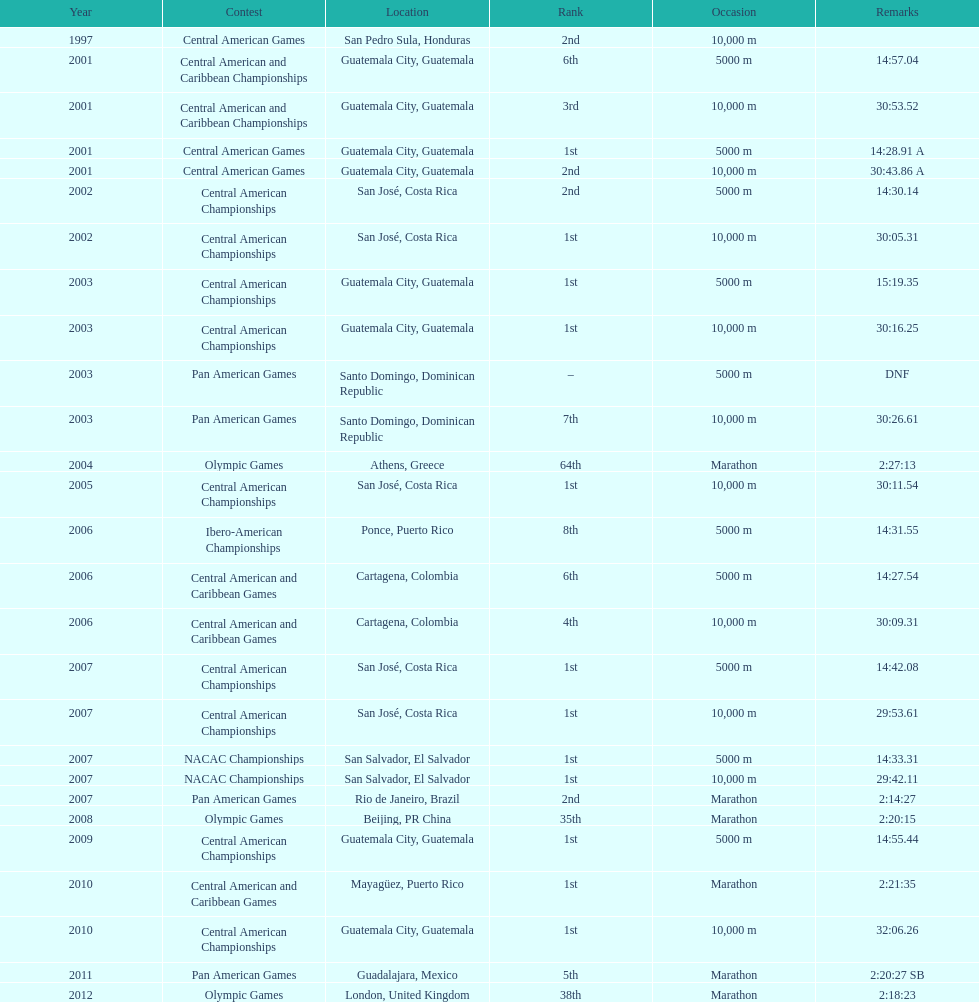How many times has the position of 1st been achieved? 12. 